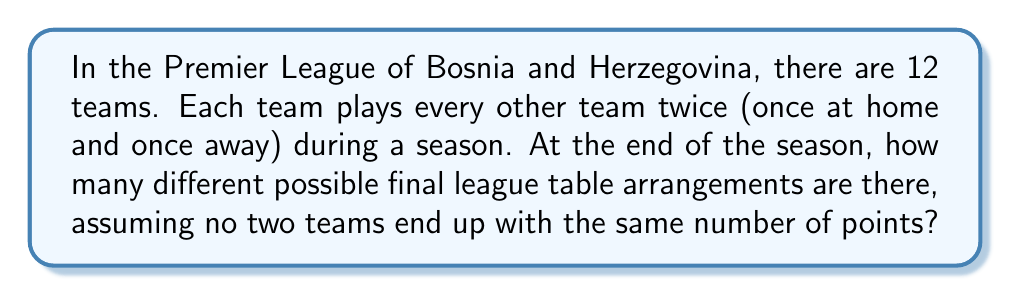Can you answer this question? Let's approach this step-by-step:

1) First, we need to understand what we're counting. We're looking for the number of ways to arrange 12 teams in a specific order from 1st to 12th place.

2) This is a straightforward permutation problem. We're arranging all 12 teams, and the order matters (1st place is different from 2nd place, etc.).

3) The formula for permutations of n distinct objects is:

   $$P(n) = n!$$

   Where $n!$ represents the factorial of n.

4) In this case, $n = 12$ (for the 12 teams in the Premier League of Bosnia and Herzegovina).

5) Therefore, the number of possible arrangements is:

   $$12! = 12 \times 11 \times 10 \times 9 \times 8 \times 7 \times 6 \times 5 \times 4 \times 3 \times 2 \times 1$$

6) Calculating this out:

   $$12! = 479,001,600$$

This means there are 479,001,600 different possible final league table arrangements, assuming no ties in points.

Note: In reality, ties in points are possible and would be resolved by goal difference or other criteria. This calculation assumes a simplified scenario where each team ends up with a unique number of points.
Answer: $479,001,600$ 